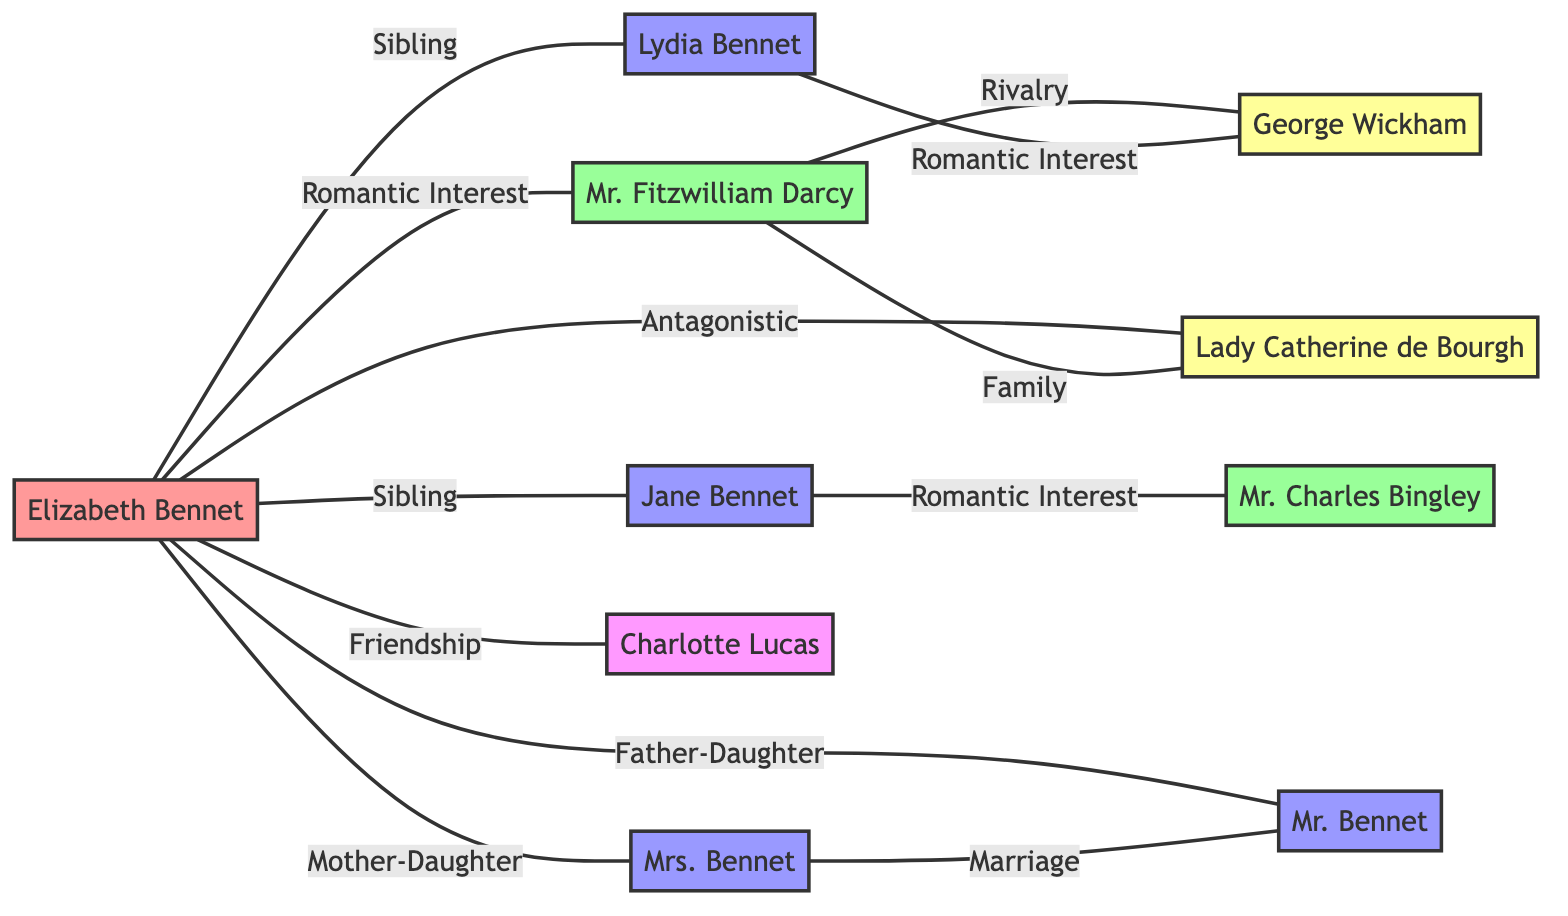What is the role of Elizabeth Bennet? The role of Elizabeth Bennet is labeled as "Protagonist" in the diagram.
Answer: Protagonist How many sisters does Elizabeth Bennet have? Elizabeth has two sisters: Jane and Lydia, as shown by the two connections labeled "Sibling" connected to her.
Answer: 2 What type of relationship exists between Jane Bennet and Mr. Charles Bingley? The diagram indicates a "Romantic Interest" relationship between Jane Bennet and Mr. Charles Bingley.
Answer: Romantic Interest Who is the antagonist related to Mr. Fitzwilliam Darcy? The diagram shows that George Wickham has a "Rivalry" relationship with Mr. Fitzwilliam Darcy, indicating him as an antagonist.
Answer: George Wickham What is the nature of the relationship between Elizabeth Bennet and Lady Catherine de Bourgh? The relationship is indicated as "Antagonistic," meaning they have opposing interests or conflicts.
Answer: Antagonistic How many total nodes are present in the diagram? By counting all the characters listed in the nodes section of the data, we see there are ten characters in total.
Answer: 10 Who is depicted as Elizabeth Bennet's friend? Charlotte Lucas is connected to Elizabeth Bennet with a "Friendship" label, showing their relationship.
Answer: Charlotte Lucas What type of relationship do Lydia Bennet and George Wickham share? The relationship between Lydia Bennet and George Wickham is categorized as "Romantic Interest," as indicated in the diagram.
Answer: Romantic Interest What role does Mrs. Bennet play in the diagram? Mrs. Bennet's role is labeled as "Mother," showing her relationship to Elizabeth and her family role.
Answer: Mother What is the total number of relationships illustrated in the diagram? By counting all the links listed, we find that there are a total of twelve relationships displayed in the diagram.
Answer: 12 